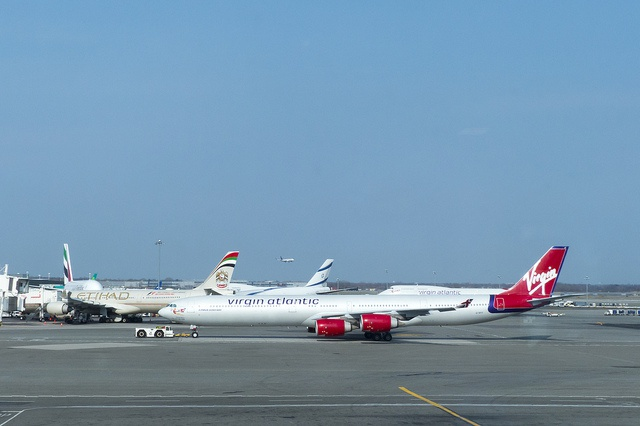Describe the objects in this image and their specific colors. I can see airplane in lightblue, white, gray, darkgray, and brown tones, airplane in lightblue, lightgray, darkgray, black, and gray tones, airplane in lightblue, lightgray, gray, and darkgray tones, airplane in lightblue, white, and darkgray tones, and airplane in lightblue, lightgray, and darkgray tones in this image. 